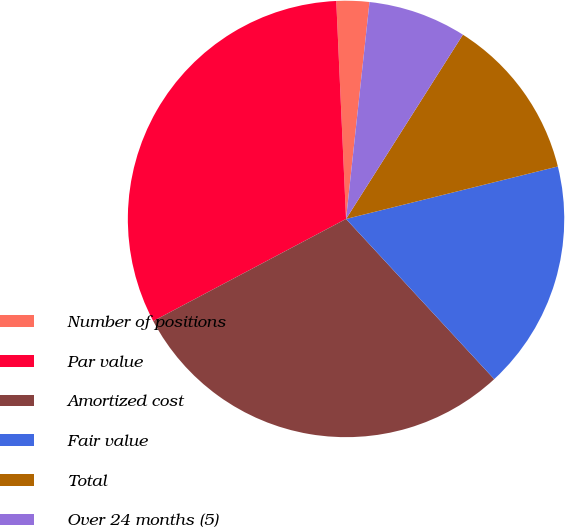Convert chart. <chart><loc_0><loc_0><loc_500><loc_500><pie_chart><fcel>Number of positions<fcel>Par value<fcel>Amortized cost<fcel>Fair value<fcel>Total<fcel>Over 24 months (5)<nl><fcel>2.43%<fcel>32.04%<fcel>29.13%<fcel>16.99%<fcel>12.14%<fcel>7.28%<nl></chart> 